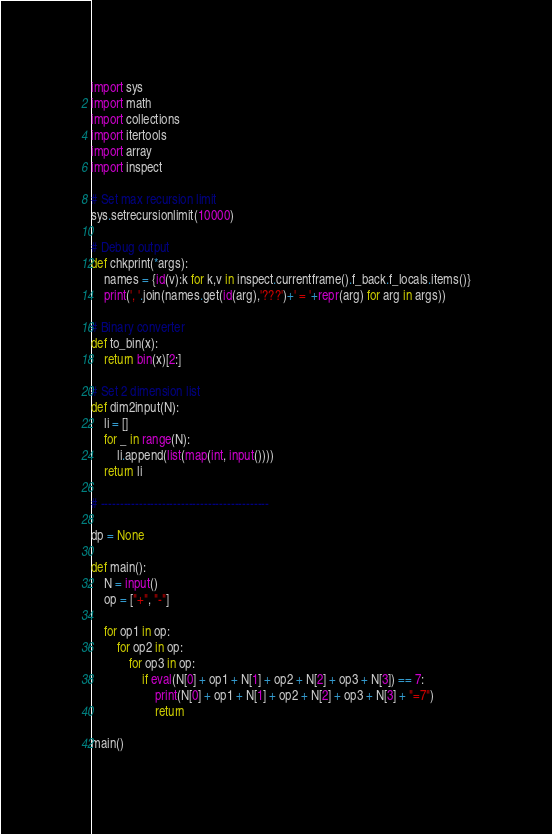<code> <loc_0><loc_0><loc_500><loc_500><_Python_>import sys
import math
import collections
import itertools
import array
import inspect

# Set max recursion limit
sys.setrecursionlimit(10000)

# Debug output
def chkprint(*args):
    names = {id(v):k for k,v in inspect.currentframe().f_back.f_locals.items()}
    print(', '.join(names.get(id(arg),'???')+' = '+repr(arg) for arg in args))

# Binary converter
def to_bin(x):
    return bin(x)[2:]

# Set 2 dimension list
def dim2input(N):
    li = []
    for _ in range(N):
        li.append(list(map(int, input())))
    return li

# --------------------------------------------

dp = None

def main():
    N = input()
    op = ["+", "-"]

    for op1 in op:
        for op2 in op:
            for op3 in op:
                if eval(N[0] + op1 + N[1] + op2 + N[2] + op3 + N[3]) == 7:
                    print(N[0] + op1 + N[1] + op2 + N[2] + op3 + N[3] + "=7")
                    return

main()
</code> 